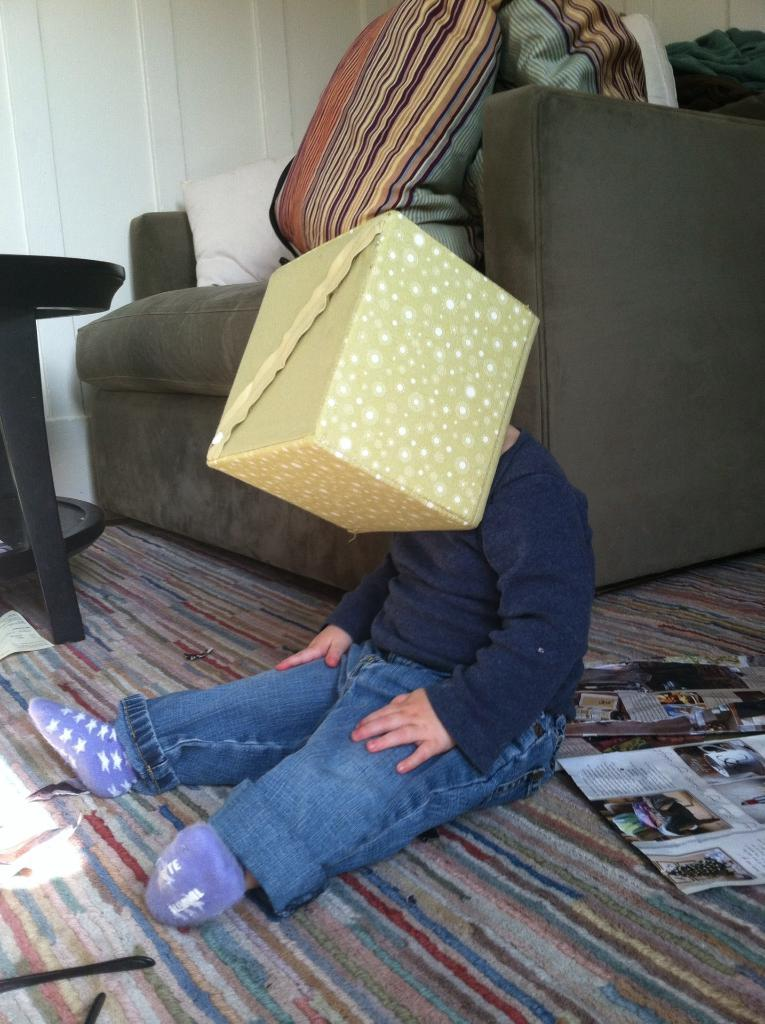What is the main subject of the image? The main subject of the image is a kid. What is on the kid's head? The kid has a box on his head. What furniture is present in the image? There is a table and a chair with a pillow in the image. What is on the chair? There are clothes on the chair. What else can be seen in the image? There are papers and other objects on the carpet. What degree does the kid have in the image? There is no indication of a degree in the image; it features a kid with a box on his head and other objects in the room. What type of polish is being applied to the objects on the carpet? There is no polish or any indication of polishing activity in the image. 